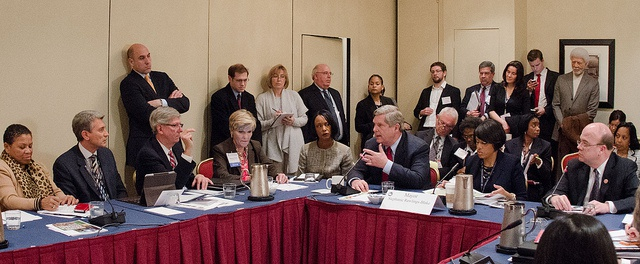Describe the objects in this image and their specific colors. I can see people in tan, black, darkgray, maroon, and brown tones, people in tan, black, lightpink, brown, and gray tones, people in tan, black, brown, gray, and lightpink tones, people in tan, black, brown, gray, and maroon tones, and people in tan, gray, and black tones in this image. 